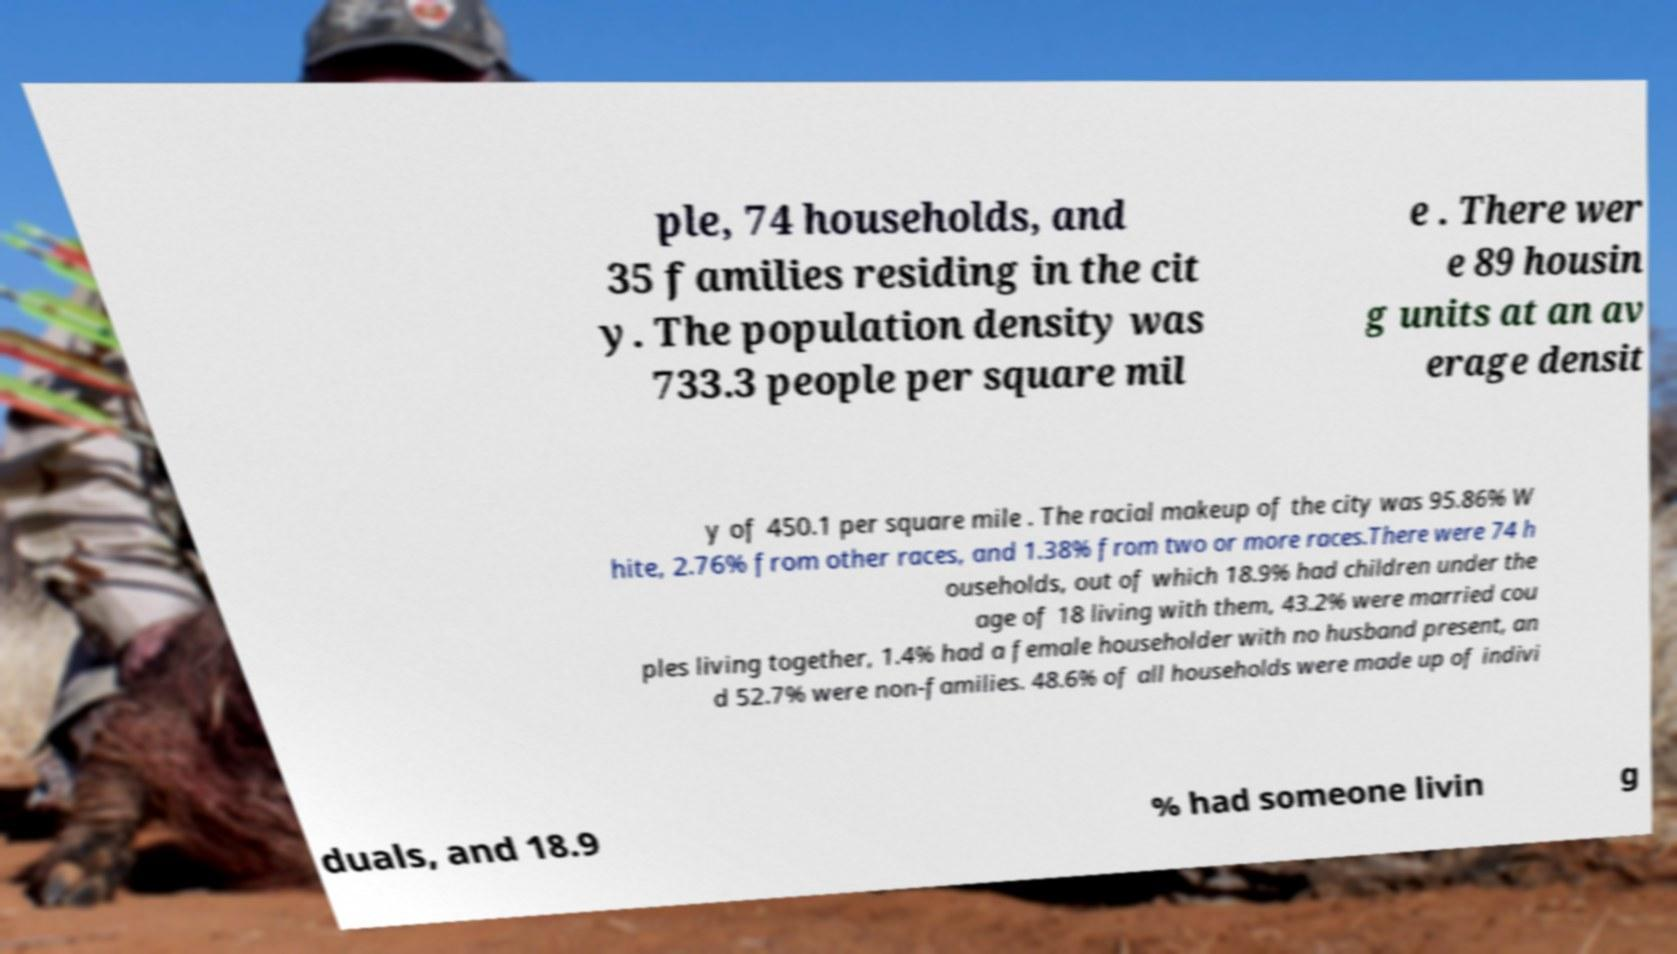Please read and relay the text visible in this image. What does it say? ple, 74 households, and 35 families residing in the cit y. The population density was 733.3 people per square mil e . There wer e 89 housin g units at an av erage densit y of 450.1 per square mile . The racial makeup of the city was 95.86% W hite, 2.76% from other races, and 1.38% from two or more races.There were 74 h ouseholds, out of which 18.9% had children under the age of 18 living with them, 43.2% were married cou ples living together, 1.4% had a female householder with no husband present, an d 52.7% were non-families. 48.6% of all households were made up of indivi duals, and 18.9 % had someone livin g 